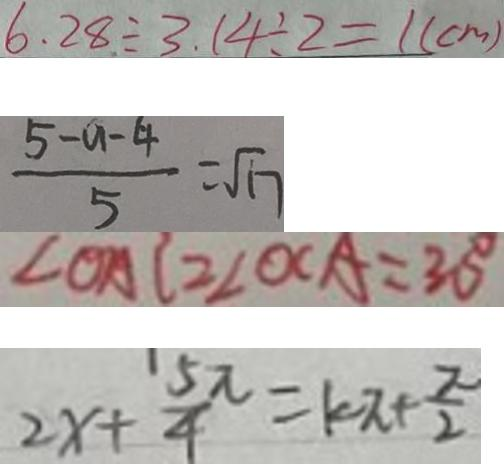<formula> <loc_0><loc_0><loc_500><loc_500>6 . 2 8 \div 3 . 1 4 \div 2 = 1 ( c m ) 
 \frac { 5 - a - 4 } { 5 } = \sqrt { 1 7 } 
 \angle O A C = \angle O C A = 3 0 ^ { \circ } 
 2 x + \frac { 5 \pi } { 4 } = k \pi + \frac { \pi } { 2 }</formula> 